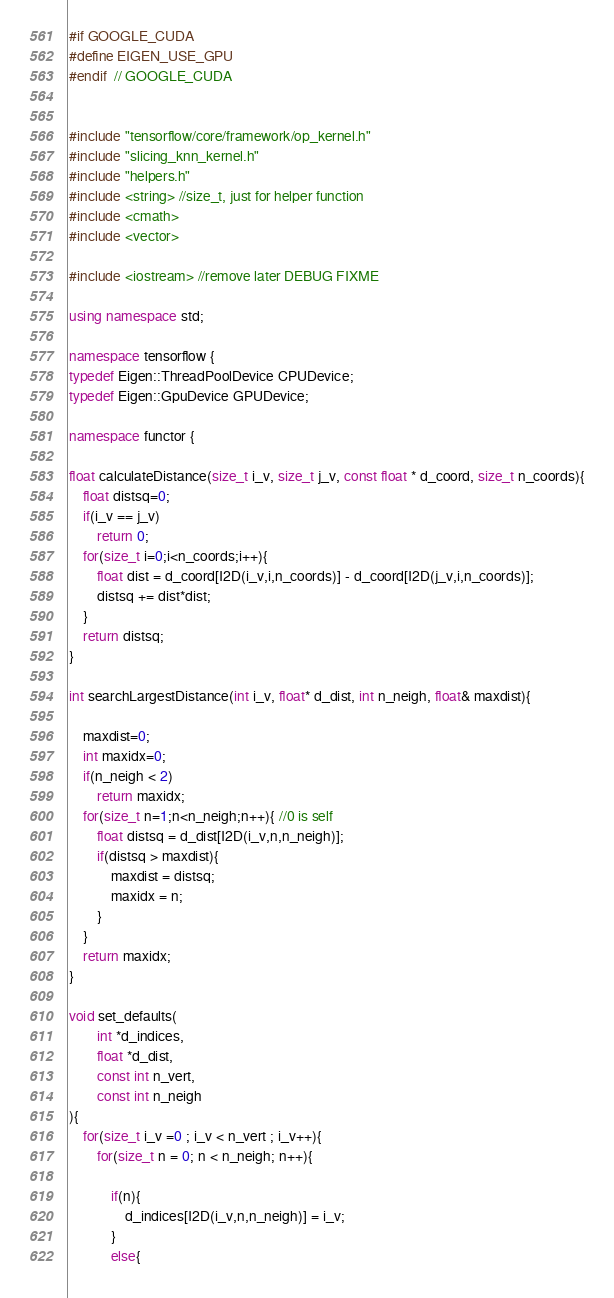<code> <loc_0><loc_0><loc_500><loc_500><_C++_>
#if GOOGLE_CUDA
#define EIGEN_USE_GPU
#endif  // GOOGLE_CUDA


#include "tensorflow/core/framework/op_kernel.h"
#include "slicing_knn_kernel.h"
#include "helpers.h"
#include <string> //size_t, just for helper function
#include <cmath>
#include <vector>

#include <iostream> //remove later DEBUG FIXME

using namespace std;

namespace tensorflow {
typedef Eigen::ThreadPoolDevice CPUDevice;
typedef Eigen::GpuDevice GPUDevice;

namespace functor {

float calculateDistance(size_t i_v, size_t j_v, const float * d_coord, size_t n_coords){
    float distsq=0;
    if(i_v == j_v)
        return 0;
    for(size_t i=0;i<n_coords;i++){
        float dist = d_coord[I2D(i_v,i,n_coords)] - d_coord[I2D(j_v,i,n_coords)];
        distsq += dist*dist;
    }
    return distsq;
}

int searchLargestDistance(int i_v, float* d_dist, int n_neigh, float& maxdist){

    maxdist=0;
    int maxidx=0;
    if(n_neigh < 2)
        return maxidx;
    for(size_t n=1;n<n_neigh;n++){ //0 is self
        float distsq = d_dist[I2D(i_v,n,n_neigh)];
        if(distsq > maxdist){
            maxdist = distsq;
            maxidx = n;
        }
    }
    return maxidx;
}

void set_defaults(
        int *d_indices,
        float *d_dist,
        const int n_vert,
        const int n_neigh
){
    for(size_t i_v =0 ; i_v < n_vert ; i_v++){
        for(size_t n = 0; n < n_neigh; n++){

            if(n){
                d_indices[I2D(i_v,n,n_neigh)] = i_v;
            }
            else{</code> 